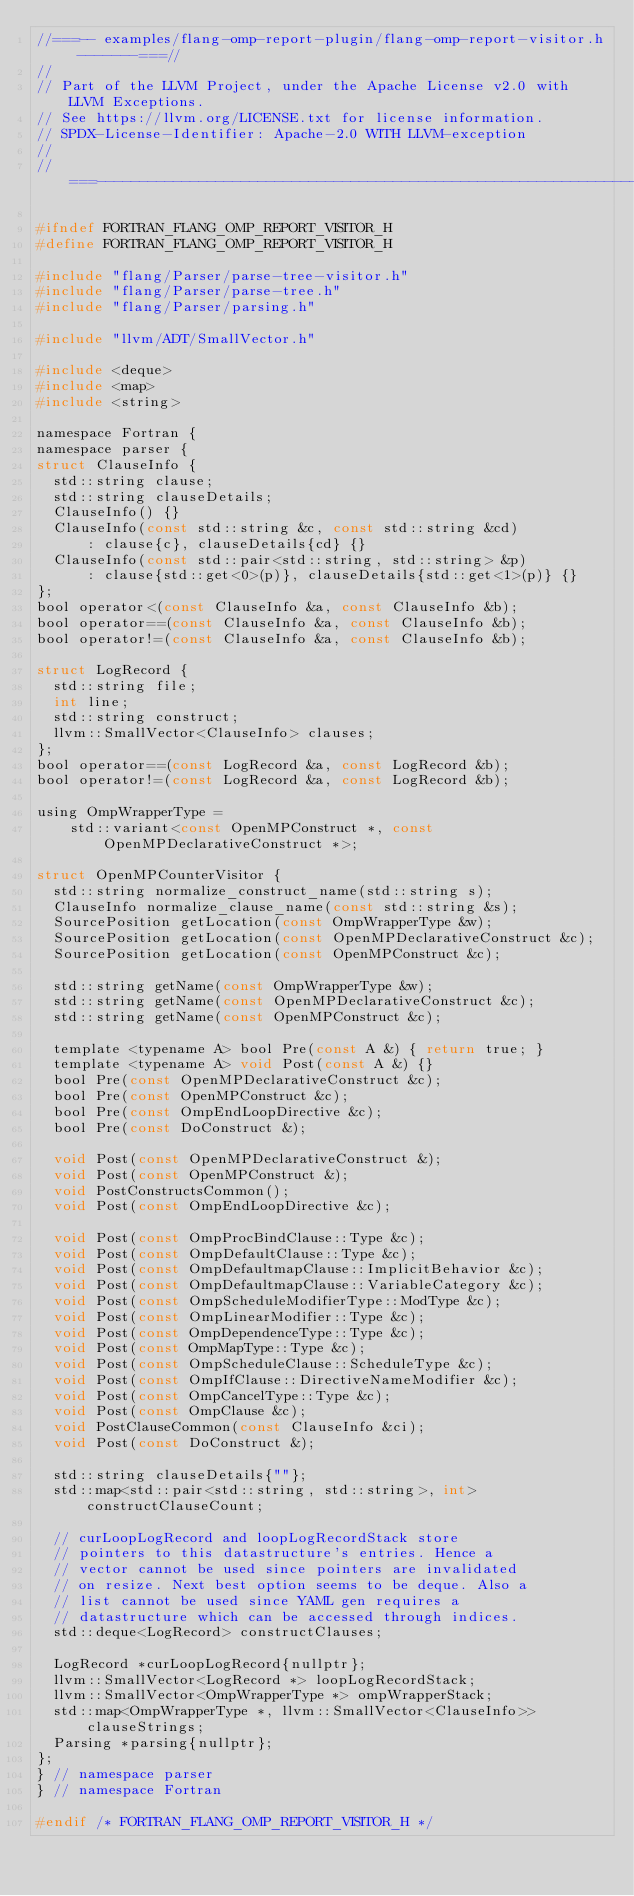<code> <loc_0><loc_0><loc_500><loc_500><_C_>//===-- examples/flang-omp-report-plugin/flang-omp-report-visitor.h -------===//
//
// Part of the LLVM Project, under the Apache License v2.0 with LLVM Exceptions.
// See https://llvm.org/LICENSE.txt for license information.
// SPDX-License-Identifier: Apache-2.0 WITH LLVM-exception
//
//===----------------------------------------------------------------------===//

#ifndef FORTRAN_FLANG_OMP_REPORT_VISITOR_H
#define FORTRAN_FLANG_OMP_REPORT_VISITOR_H

#include "flang/Parser/parse-tree-visitor.h"
#include "flang/Parser/parse-tree.h"
#include "flang/Parser/parsing.h"

#include "llvm/ADT/SmallVector.h"

#include <deque>
#include <map>
#include <string>

namespace Fortran {
namespace parser {
struct ClauseInfo {
  std::string clause;
  std::string clauseDetails;
  ClauseInfo() {}
  ClauseInfo(const std::string &c, const std::string &cd)
      : clause{c}, clauseDetails{cd} {}
  ClauseInfo(const std::pair<std::string, std::string> &p)
      : clause{std::get<0>(p)}, clauseDetails{std::get<1>(p)} {}
};
bool operator<(const ClauseInfo &a, const ClauseInfo &b);
bool operator==(const ClauseInfo &a, const ClauseInfo &b);
bool operator!=(const ClauseInfo &a, const ClauseInfo &b);

struct LogRecord {
  std::string file;
  int line;
  std::string construct;
  llvm::SmallVector<ClauseInfo> clauses;
};
bool operator==(const LogRecord &a, const LogRecord &b);
bool operator!=(const LogRecord &a, const LogRecord &b);

using OmpWrapperType =
    std::variant<const OpenMPConstruct *, const OpenMPDeclarativeConstruct *>;

struct OpenMPCounterVisitor {
  std::string normalize_construct_name(std::string s);
  ClauseInfo normalize_clause_name(const std::string &s);
  SourcePosition getLocation(const OmpWrapperType &w);
  SourcePosition getLocation(const OpenMPDeclarativeConstruct &c);
  SourcePosition getLocation(const OpenMPConstruct &c);

  std::string getName(const OmpWrapperType &w);
  std::string getName(const OpenMPDeclarativeConstruct &c);
  std::string getName(const OpenMPConstruct &c);

  template <typename A> bool Pre(const A &) { return true; }
  template <typename A> void Post(const A &) {}
  bool Pre(const OpenMPDeclarativeConstruct &c);
  bool Pre(const OpenMPConstruct &c);
  bool Pre(const OmpEndLoopDirective &c);
  bool Pre(const DoConstruct &);

  void Post(const OpenMPDeclarativeConstruct &);
  void Post(const OpenMPConstruct &);
  void PostConstructsCommon();
  void Post(const OmpEndLoopDirective &c);

  void Post(const OmpProcBindClause::Type &c);
  void Post(const OmpDefaultClause::Type &c);
  void Post(const OmpDefaultmapClause::ImplicitBehavior &c);
  void Post(const OmpDefaultmapClause::VariableCategory &c);
  void Post(const OmpScheduleModifierType::ModType &c);
  void Post(const OmpLinearModifier::Type &c);
  void Post(const OmpDependenceType::Type &c);
  void Post(const OmpMapType::Type &c);
  void Post(const OmpScheduleClause::ScheduleType &c);
  void Post(const OmpIfClause::DirectiveNameModifier &c);
  void Post(const OmpCancelType::Type &c);
  void Post(const OmpClause &c);
  void PostClauseCommon(const ClauseInfo &ci);
  void Post(const DoConstruct &);

  std::string clauseDetails{""};
  std::map<std::pair<std::string, std::string>, int> constructClauseCount;

  // curLoopLogRecord and loopLogRecordStack store
  // pointers to this datastructure's entries. Hence a
  // vector cannot be used since pointers are invalidated
  // on resize. Next best option seems to be deque. Also a
  // list cannot be used since YAML gen requires a
  // datastructure which can be accessed through indices.
  std::deque<LogRecord> constructClauses;

  LogRecord *curLoopLogRecord{nullptr};
  llvm::SmallVector<LogRecord *> loopLogRecordStack;
  llvm::SmallVector<OmpWrapperType *> ompWrapperStack;
  std::map<OmpWrapperType *, llvm::SmallVector<ClauseInfo>> clauseStrings;
  Parsing *parsing{nullptr};
};
} // namespace parser
} // namespace Fortran

#endif /* FORTRAN_FLANG_OMP_REPORT_VISITOR_H */
</code> 